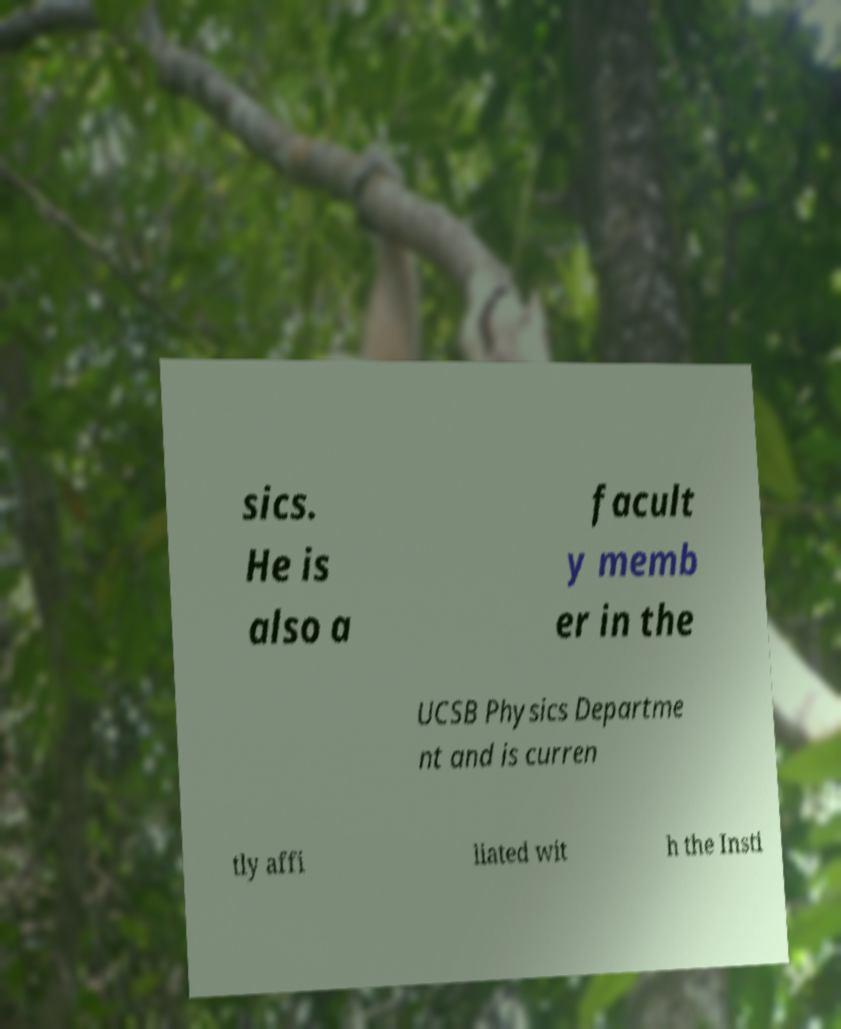For documentation purposes, I need the text within this image transcribed. Could you provide that? sics. He is also a facult y memb er in the UCSB Physics Departme nt and is curren tly affi liated wit h the Insti 